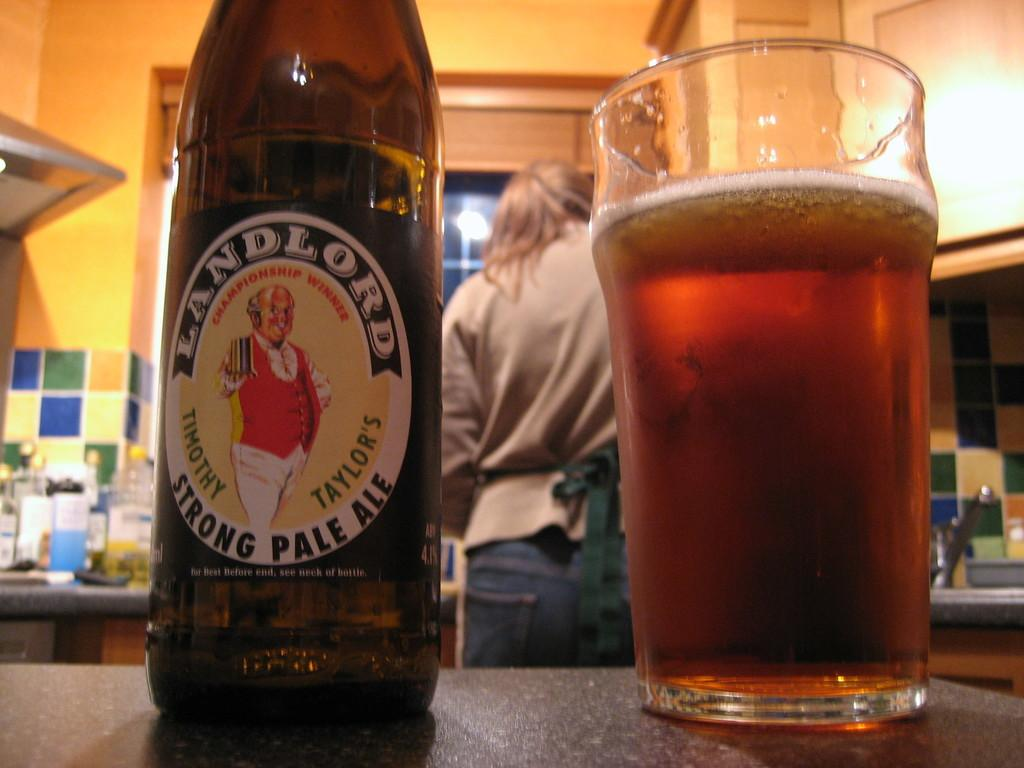Provide a one-sentence caption for the provided image. A bottle of Landlord Strong Pale Ale is placed next to a glass half full of beer. 